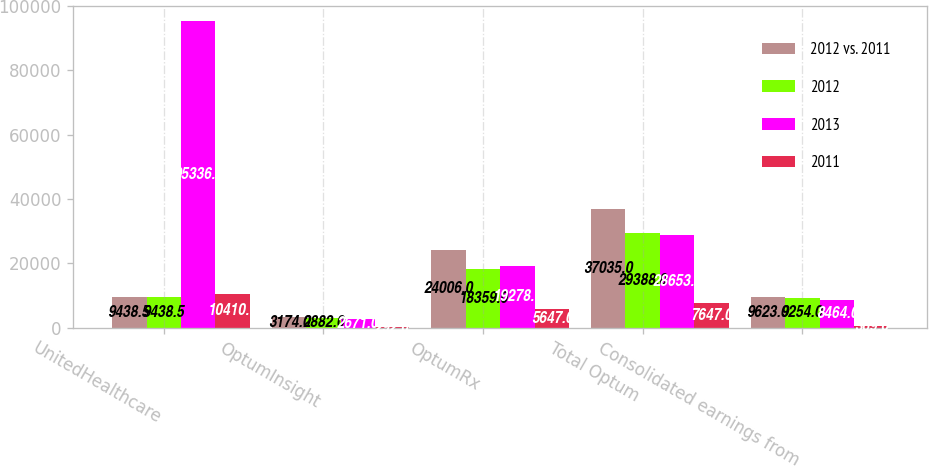Convert chart to OTSL. <chart><loc_0><loc_0><loc_500><loc_500><stacked_bar_chart><ecel><fcel>UnitedHealthcare<fcel>OptumInsight<fcel>OptumRx<fcel>Total Optum<fcel>Consolidated earnings from<nl><fcel>2012 vs. 2011<fcel>9438.5<fcel>3174<fcel>24006<fcel>37035<fcel>9623<nl><fcel>2012<fcel>9438.5<fcel>2882<fcel>18359<fcel>29388<fcel>9254<nl><fcel>2013<fcel>95336<fcel>2671<fcel>19278<fcel>28653<fcel>8464<nl><fcel>2011<fcel>10410<fcel>292<fcel>5647<fcel>7647<fcel>369<nl></chart> 